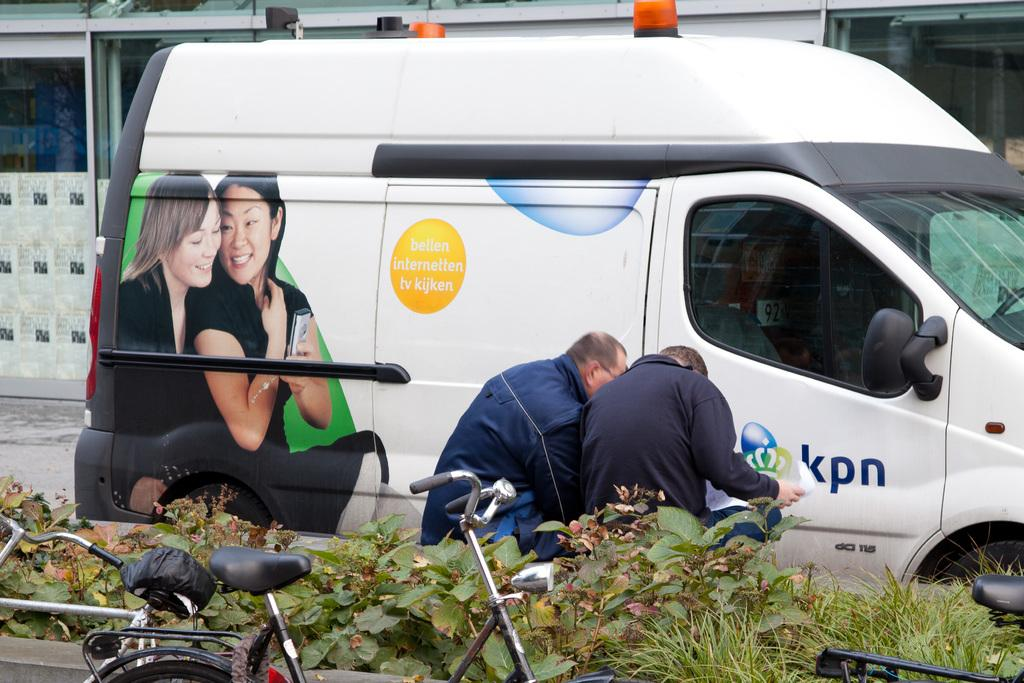Provide a one-sentence caption for the provided image. A van has the phrase "bellen internetten tv kijken" on the side of it. 